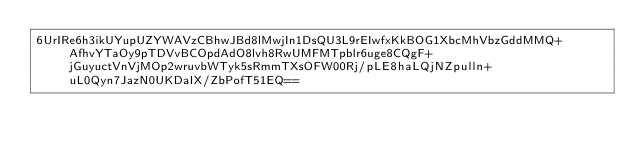<code> <loc_0><loc_0><loc_500><loc_500><_SML_>6UrIRe6h3ikUYupUZYWAVzCBhwJBd8lMwjIn1DsQU3L9rEIwfxKkBOG1XbcMhVbzGddMMQ+AfhvYTaOy9pTDVvBCOpdAdO8lvh8RwUMFMTpblr6uge8CQgF+jGuyuctVnVjMOp2wruvbWTyk5sRmmTXsOFW00Rj/pLE8haLQjNZpulln+uL0Qyn7JazN0UKDaIX/ZbPofT51EQ==</code> 